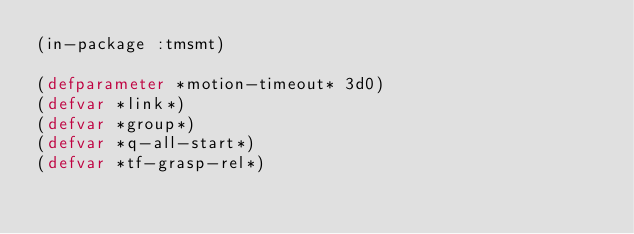Convert code to text. <code><loc_0><loc_0><loc_500><loc_500><_Lisp_>(in-package :tmsmt)

(defparameter *motion-timeout* 3d0)
(defvar *link*)
(defvar *group*)
(defvar *q-all-start*)
(defvar *tf-grasp-rel*)
</code> 